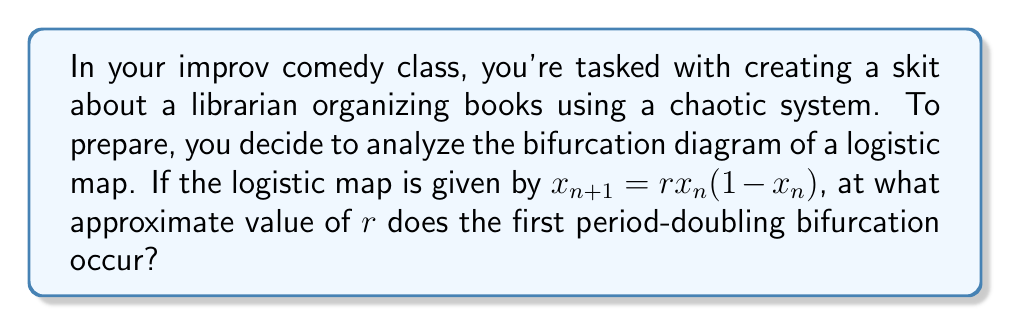Can you solve this math problem? Let's approach this step-by-step:

1) The logistic map is given by the equation $x_{n+1} = rx_n(1-x_n)$, where $r$ is a parameter.

2) In a bifurcation diagram, we plot the long-term behavior of $x$ against different values of $r$.

3) For small values of $r$ (0 < $r$ < 1), the system converges to 0.

4) As $r$ increases beyond 1, the system converges to a single non-zero value.

5) The first period-doubling bifurcation occurs when the system transitions from a single stable point to an oscillation between two values.

6) This first bifurcation can be found analytically by solving the equation:

   $$r(1-2x^*) = -1$$

   where $x^*$ is the fixed point of the system.

7) The fixed point $x^*$ can be found by solving:

   $$x^* = rx^*(1-x^*)$$

8) Solving this, we get $x^* = 1 - \frac{1}{r}$

9) Substituting this into the equation from step 6:

   $$r(1-2(1-\frac{1}{r})) = -1$$

10) Simplifying:

    $$r(\frac{2}{r}-1) = -1$$
    $$2-r = -1$$
    $$r = 3$$

Therefore, the first period-doubling bifurcation occurs at $r = 3$.
Answer: 3 